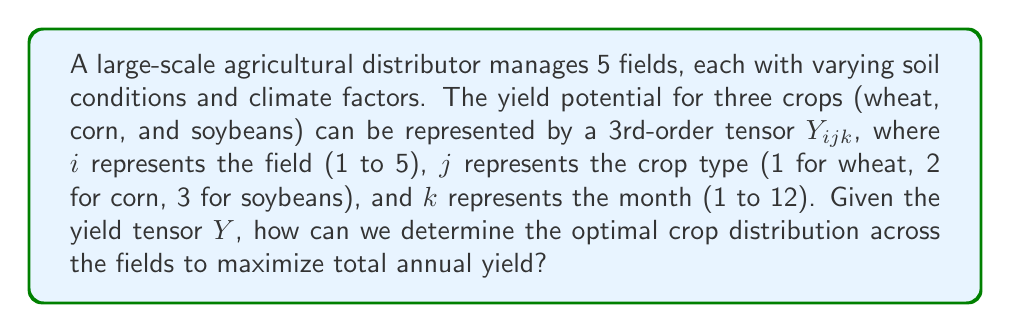Can you answer this question? To solve this problem, we'll use tensor operations to maximize the total yield:

1. First, we need to sum the yields over all months for each field and crop combination. This can be done using tensor contraction along the third dimension:

   $$A_{ij} = \sum_{k=1}^{12} Y_{ijk}$$

   $A_{ij}$ now represents the annual yield for each field-crop combination.

2. To find the optimal distribution, we need to maximize the sum of selected elements from $A_{ij}$. We can represent our crop selection with a binary tensor $X_{ij}$, where:

   $$X_{ij} = \begin{cases}
   1 & \text{if crop } j \text{ is planted in field } i \\
   0 & \text{otherwise}
   \end{cases}$$

3. The total yield can be expressed as the element-wise product of $A$ and $X$, summed over all elements:

   $$\text{Total Yield} = \sum_{i=1}^{5} \sum_{j=1}^{3} A_{ij}X_{ij}$$

4. Our optimization problem becomes:

   $$\max_{X} \sum_{i=1}^{5} \sum_{j=1}^{3} A_{ij}X_{ij}$$

   Subject to the constraints:
   - $\sum_{j=1}^{3} X_{ij} = 1$ for all $i$ (each field must have exactly one crop)
   - $X_{ij} \in \{0, 1\}$ for all $i,j$ (binary decision variables)

5. This is an integer programming problem, which can be solved using methods like branch and bound or dynamic programming.

6. The solution $X_{ij}$ will give us the optimal crop distribution across the fields.

7. The maximum total annual yield will be the value of the objective function at the optimal solution.
Answer: $$\max_{X} \sum_{i=1}^{5} \sum_{j=1}^{3} A_{ij}X_{ij}, \text{ where } A_{ij} = \sum_{k=1}^{12} Y_{ijk}$$ 